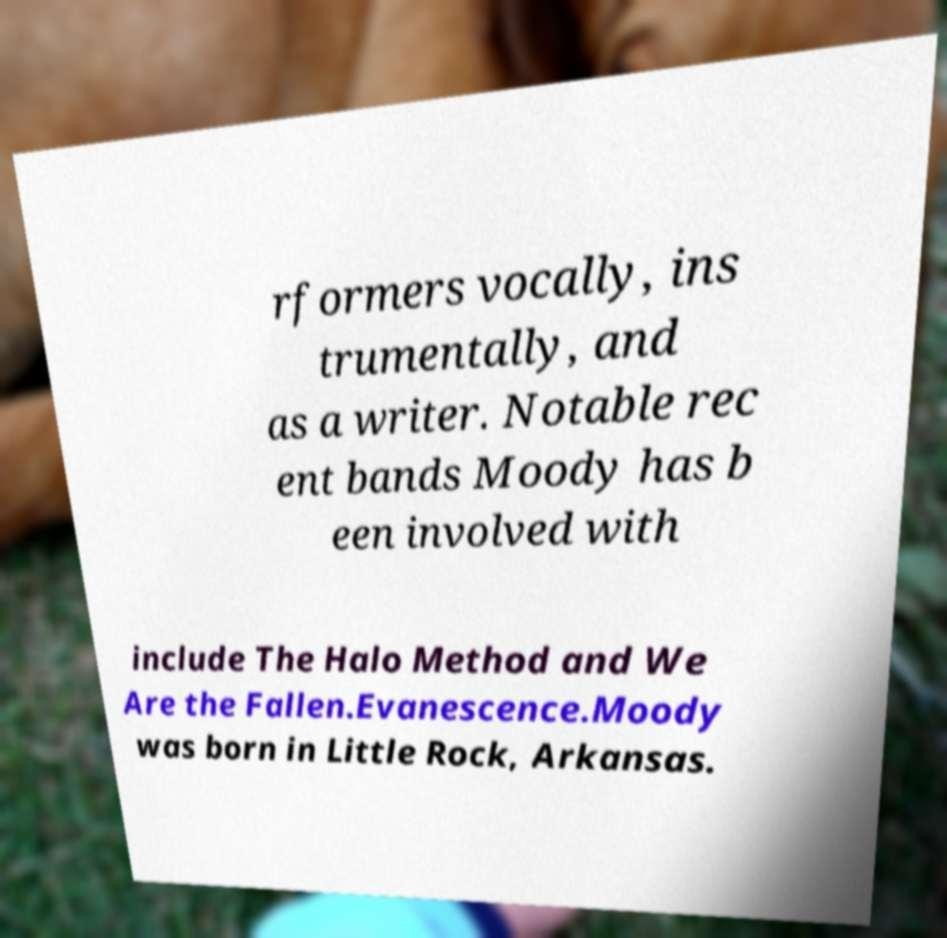There's text embedded in this image that I need extracted. Can you transcribe it verbatim? rformers vocally, ins trumentally, and as a writer. Notable rec ent bands Moody has b een involved with include The Halo Method and We Are the Fallen.Evanescence.Moody was born in Little Rock, Arkansas. 